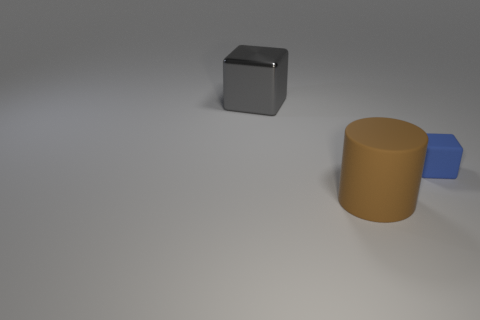Are there any other things that are the same size as the matte block?
Give a very brief answer. No. Is there anything else that is the same shape as the large matte thing?
Your answer should be very brief. No. What size is the blue cube?
Ensure brevity in your answer.  Small. There is a blue cube; how many brown rubber objects are behind it?
Your answer should be compact. 0. There is a block to the left of the block right of the large block; what size is it?
Keep it short and to the point. Large. Do the thing behind the tiny blue object and the rubber thing that is to the right of the big brown thing have the same shape?
Keep it short and to the point. Yes. What shape is the big object right of the object left of the large cylinder?
Give a very brief answer. Cylinder. There is a object that is both in front of the gray metal thing and behind the big matte thing; what is its size?
Provide a succinct answer. Small. Is the shape of the blue object the same as the large object that is behind the brown rubber object?
Make the answer very short. Yes. What is the size of the other gray thing that is the same shape as the tiny matte thing?
Provide a short and direct response. Large. 